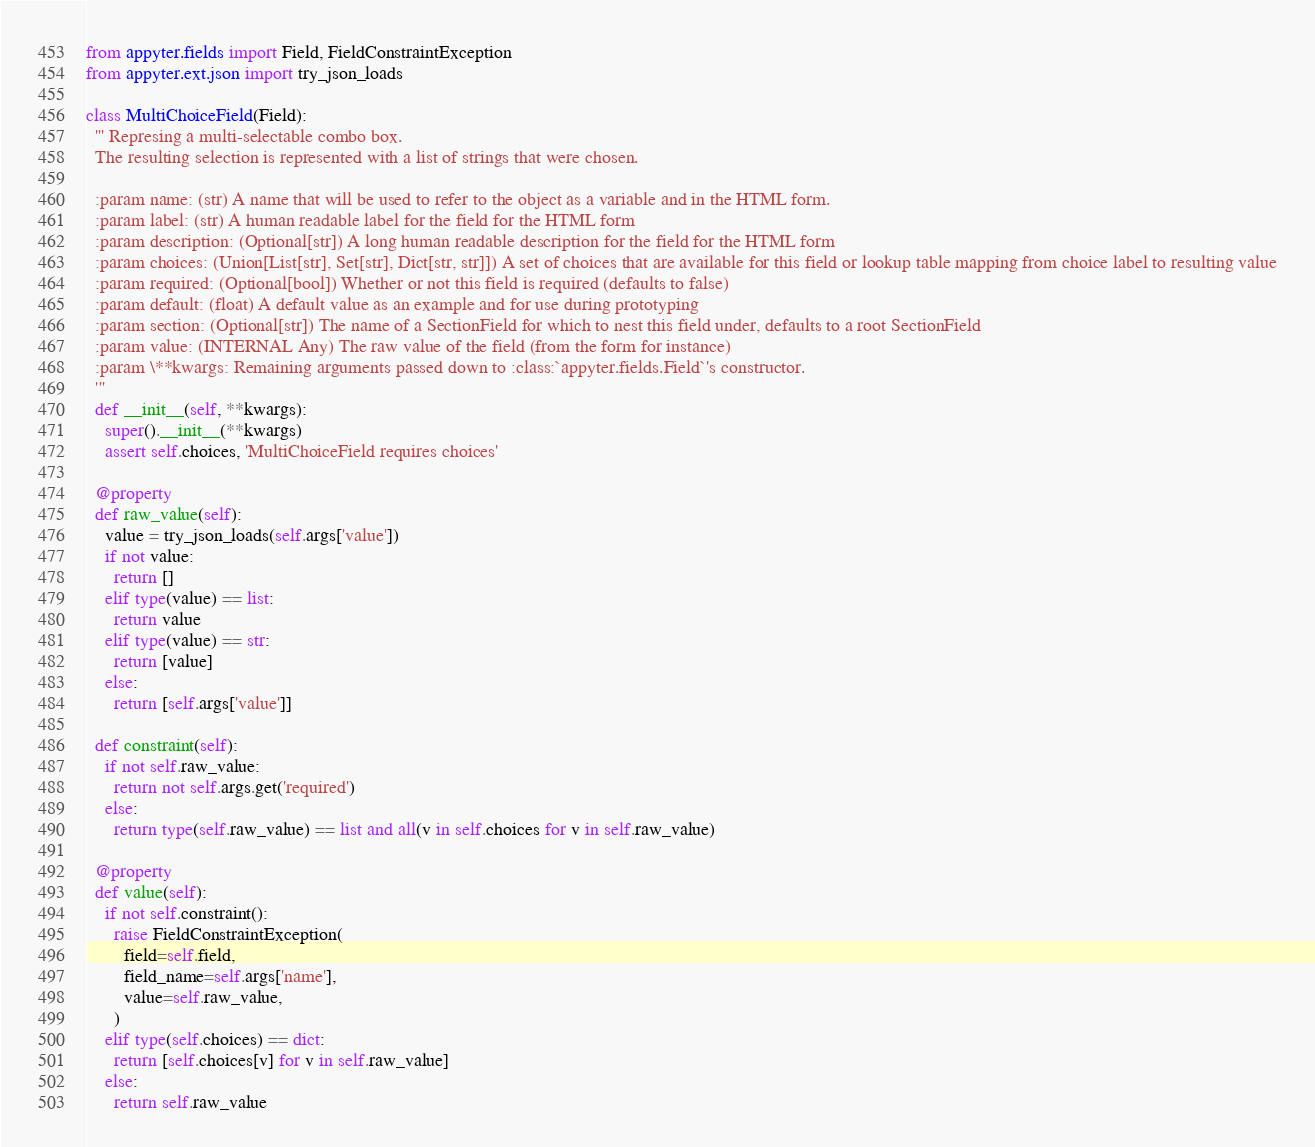<code> <loc_0><loc_0><loc_500><loc_500><_Python_>from appyter.fields import Field, FieldConstraintException
from appyter.ext.json import try_json_loads

class MultiChoiceField(Field):
  ''' Represing a multi-selectable combo box.
  The resulting selection is represented with a list of strings that were chosen.

  :param name: (str) A name that will be used to refer to the object as a variable and in the HTML form.
  :param label: (str) A human readable label for the field for the HTML form
  :param description: (Optional[str]) A long human readable description for the field for the HTML form
  :param choices: (Union[List[str], Set[str], Dict[str, str]]) A set of choices that are available for this field or lookup table mapping from choice label to resulting value
  :param required: (Optional[bool]) Whether or not this field is required (defaults to false)
  :param default: (float) A default value as an example and for use during prototyping
  :param section: (Optional[str]) The name of a SectionField for which to nest this field under, defaults to a root SectionField
  :param value: (INTERNAL Any) The raw value of the field (from the form for instance)
  :param \**kwargs: Remaining arguments passed down to :class:`appyter.fields.Field`'s constructor.
  '''
  def __init__(self, **kwargs):
    super().__init__(**kwargs)
    assert self.choices, 'MultiChoiceField requires choices'

  @property
  def raw_value(self):
    value = try_json_loads(self.args['value'])
    if not value:
      return []
    elif type(value) == list:
      return value
    elif type(value) == str:
      return [value]
    else:
      return [self.args['value']]

  def constraint(self):
    if not self.raw_value:
      return not self.args.get('required')
    else:
      return type(self.raw_value) == list and all(v in self.choices for v in self.raw_value)

  @property
  def value(self):
    if not self.constraint():
      raise FieldConstraintException(
        field=self.field,
        field_name=self.args['name'],
        value=self.raw_value,
      )
    elif type(self.choices) == dict:
      return [self.choices[v] for v in self.raw_value]
    else:
      return self.raw_value
</code> 